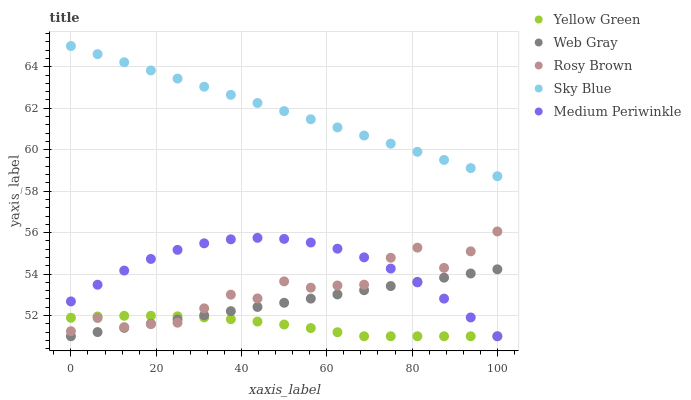Does Yellow Green have the minimum area under the curve?
Answer yes or no. Yes. Does Sky Blue have the maximum area under the curve?
Answer yes or no. Yes. Does Rosy Brown have the minimum area under the curve?
Answer yes or no. No. Does Rosy Brown have the maximum area under the curve?
Answer yes or no. No. Is Sky Blue the smoothest?
Answer yes or no. Yes. Is Rosy Brown the roughest?
Answer yes or no. Yes. Is Web Gray the smoothest?
Answer yes or no. No. Is Web Gray the roughest?
Answer yes or no. No. Does Web Gray have the lowest value?
Answer yes or no. Yes. Does Rosy Brown have the lowest value?
Answer yes or no. No. Does Sky Blue have the highest value?
Answer yes or no. Yes. Does Rosy Brown have the highest value?
Answer yes or no. No. Is Yellow Green less than Sky Blue?
Answer yes or no. Yes. Is Sky Blue greater than Web Gray?
Answer yes or no. Yes. Does Medium Periwinkle intersect Yellow Green?
Answer yes or no. Yes. Is Medium Periwinkle less than Yellow Green?
Answer yes or no. No. Is Medium Periwinkle greater than Yellow Green?
Answer yes or no. No. Does Yellow Green intersect Sky Blue?
Answer yes or no. No. 